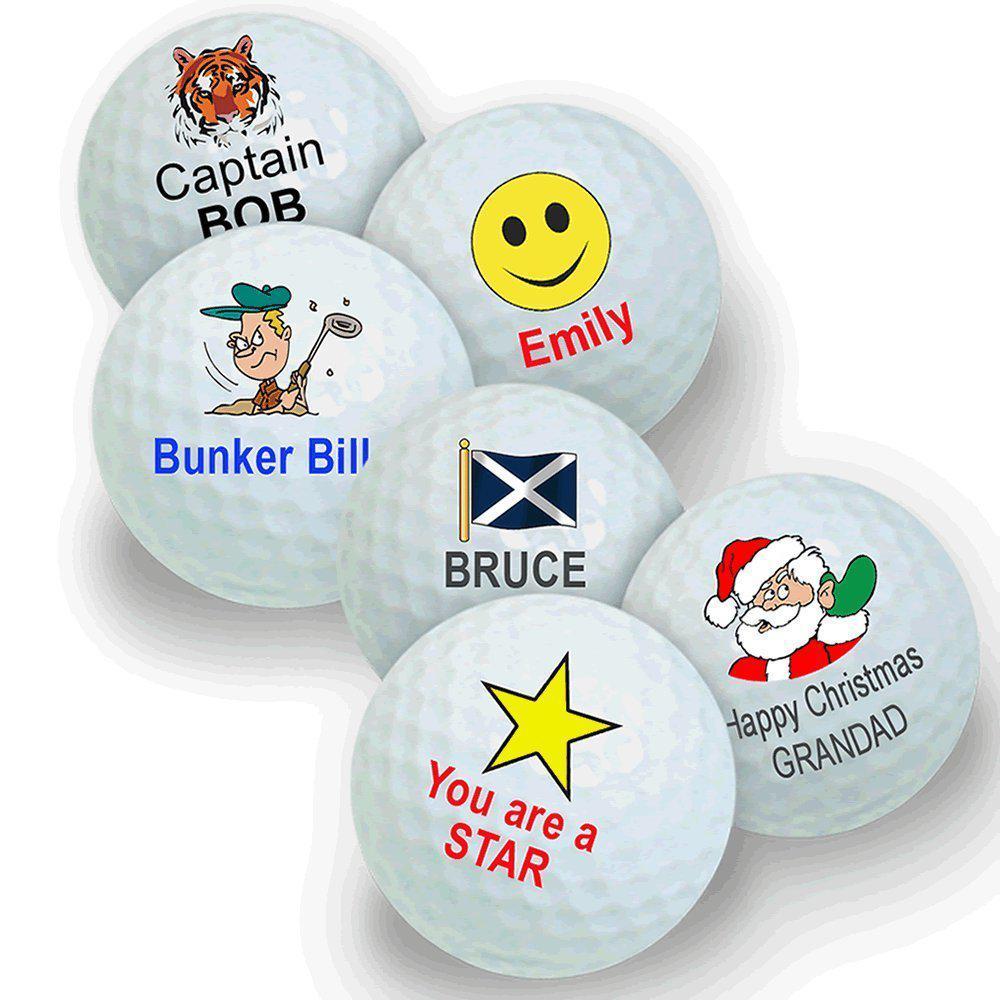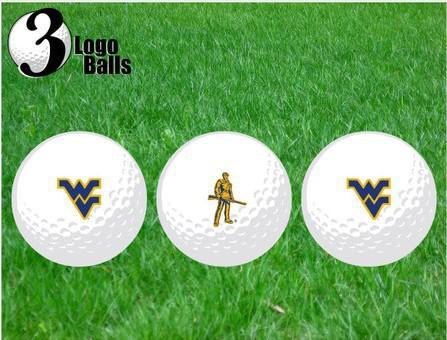The first image is the image on the left, the second image is the image on the right. Given the left and right images, does the statement "The balls in the image on the left are on the grass." hold true? Answer yes or no. No. The first image is the image on the left, the second image is the image on the right. Evaluate the accuracy of this statement regarding the images: "An image shows at least one golf ball on the green ground near a hole.". Is it true? Answer yes or no. No. 